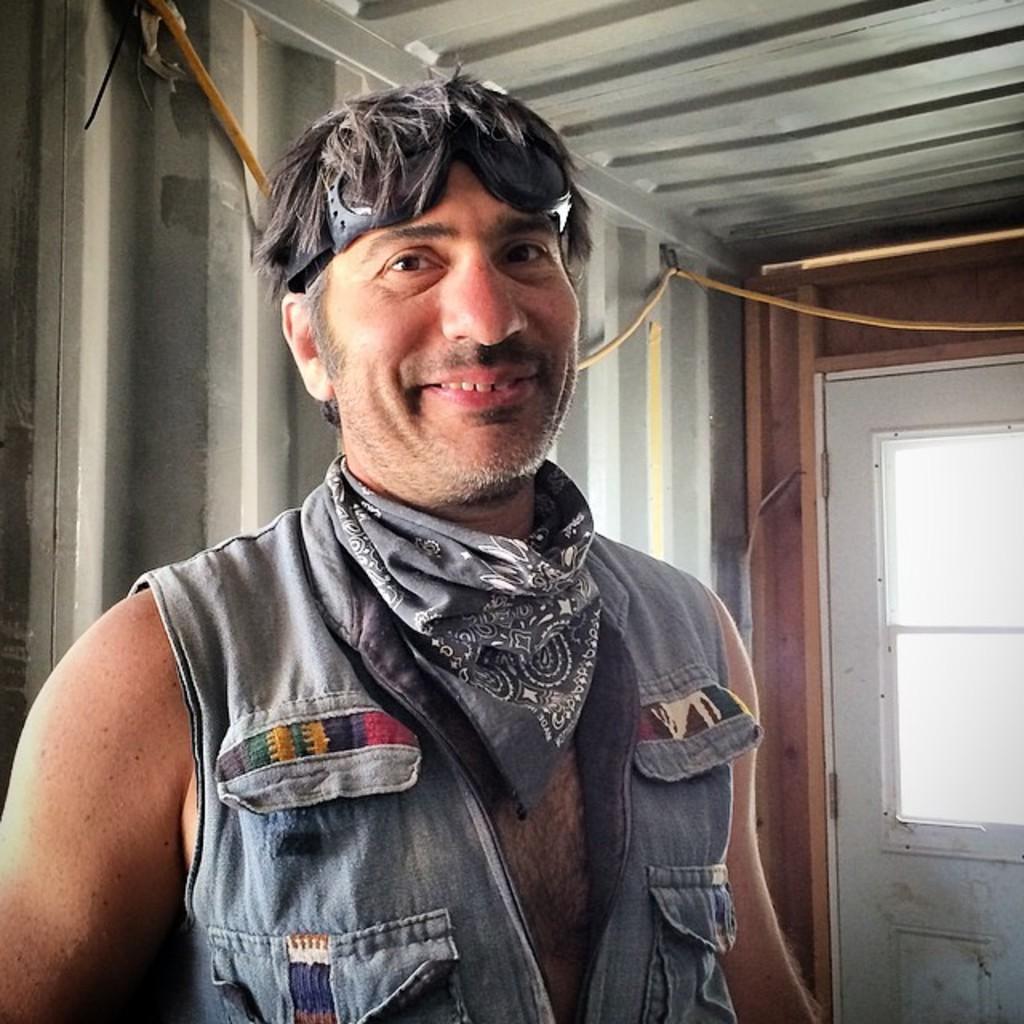How would you summarize this image in a sentence or two? In this image we can see a person, there are some pillars and a rope, on the right side of the image we can see a window. 